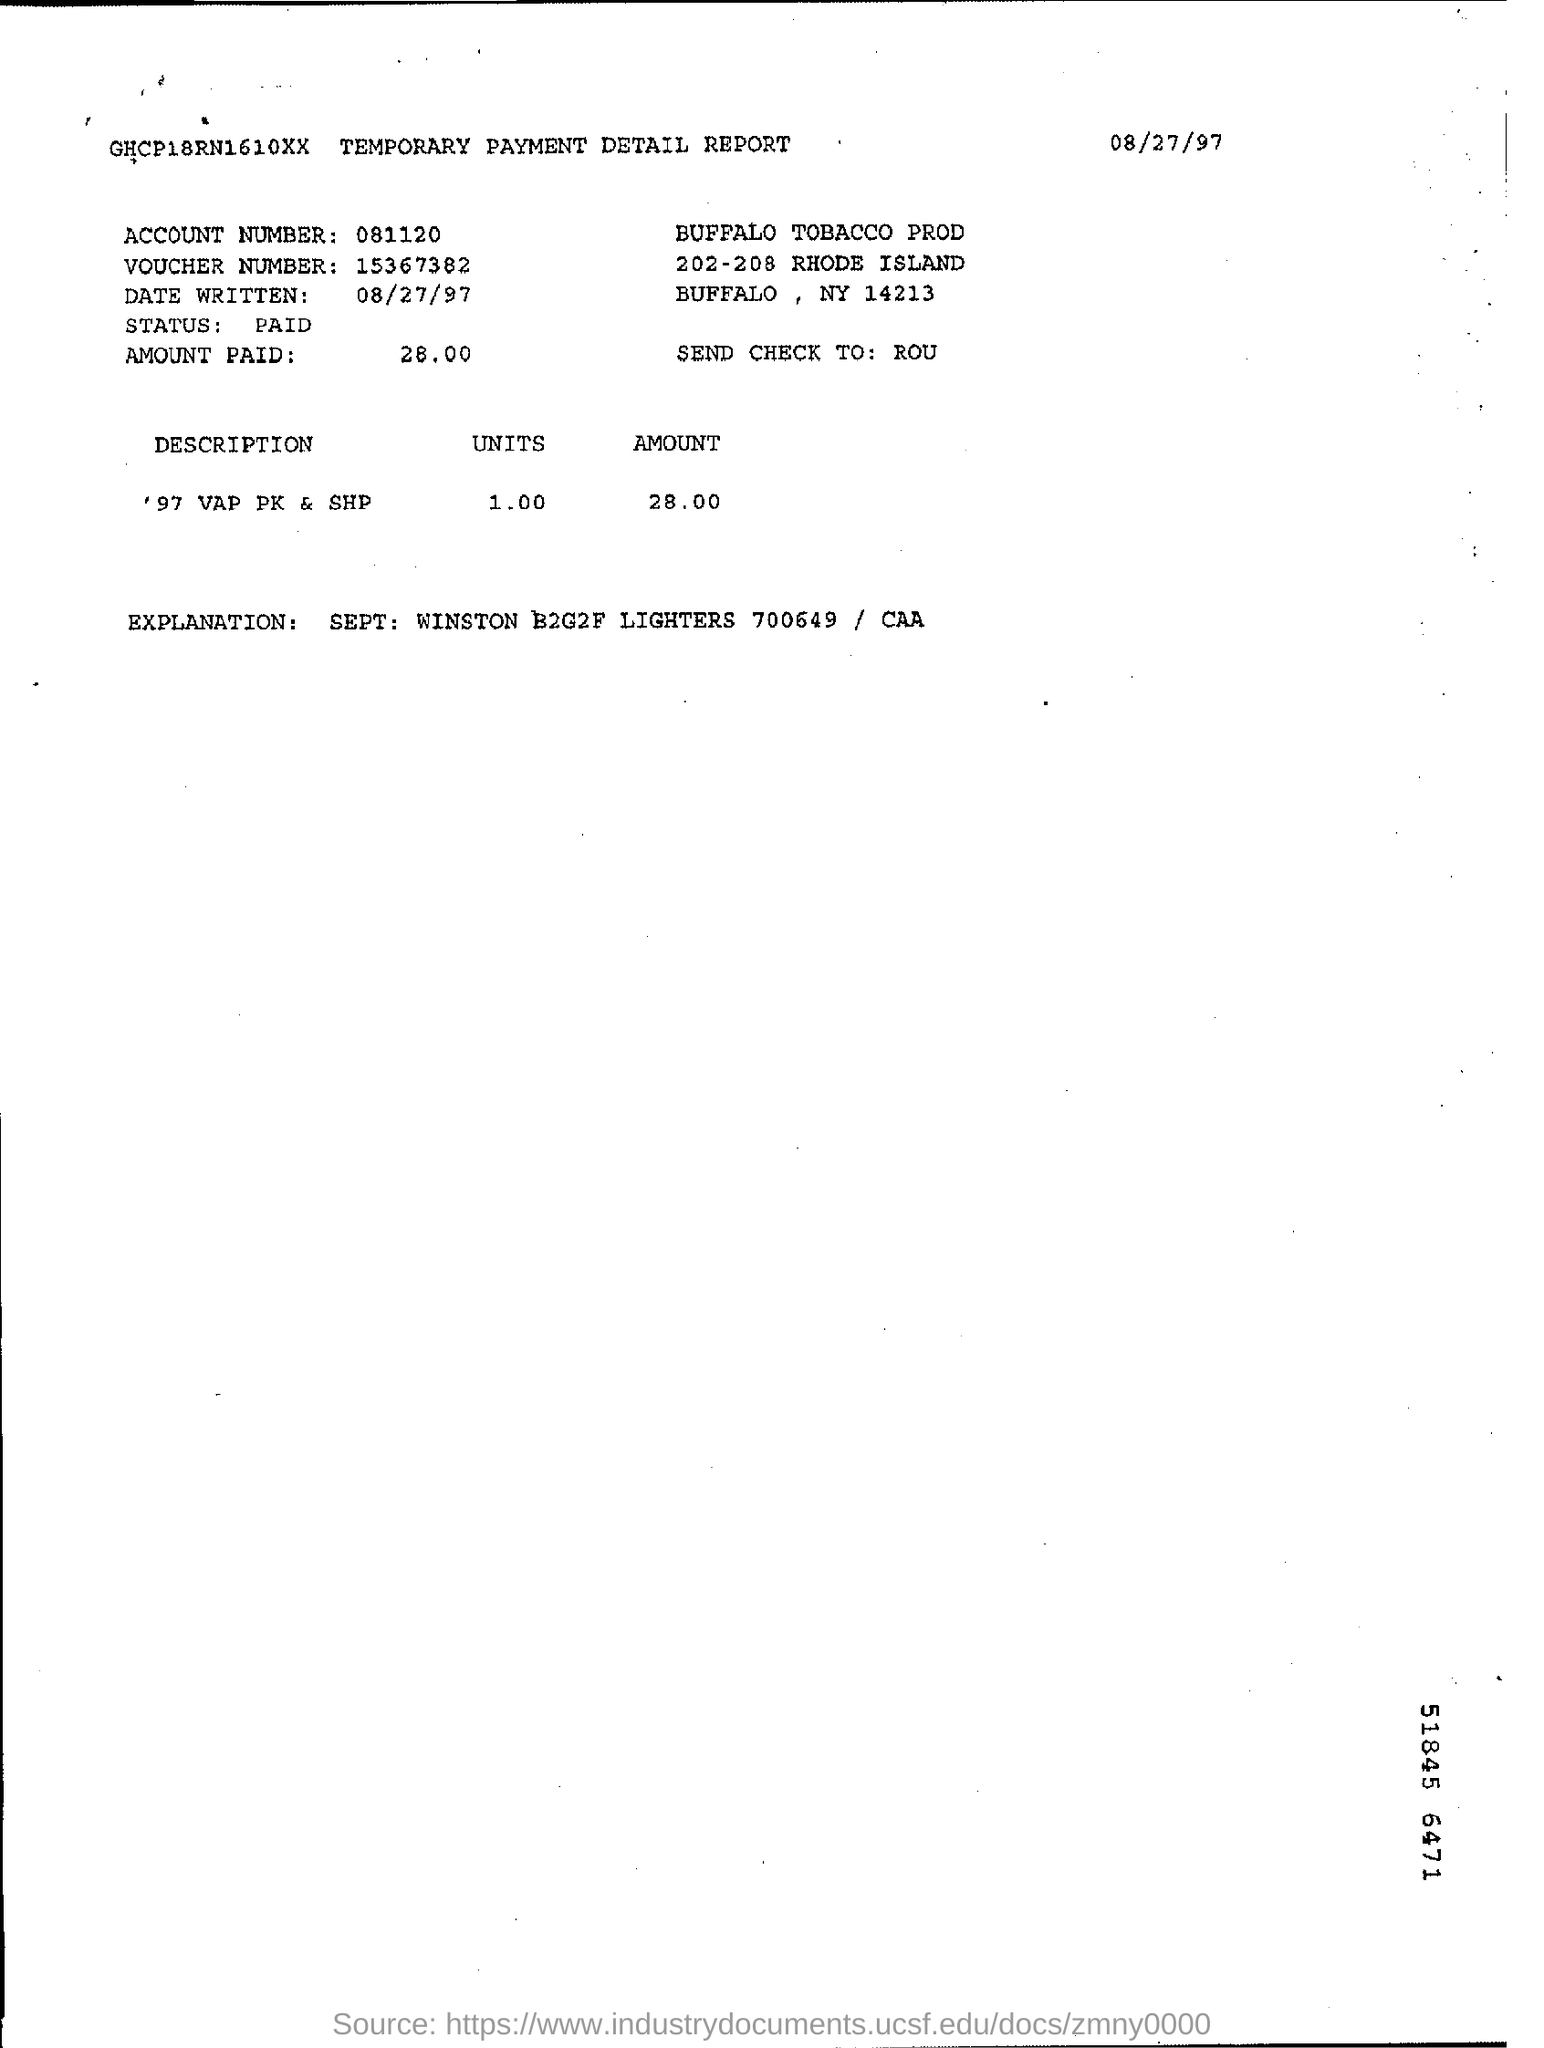Draw attention to some important aspects in this diagram. The amount paid is 28.00. The voucher has been paid. 